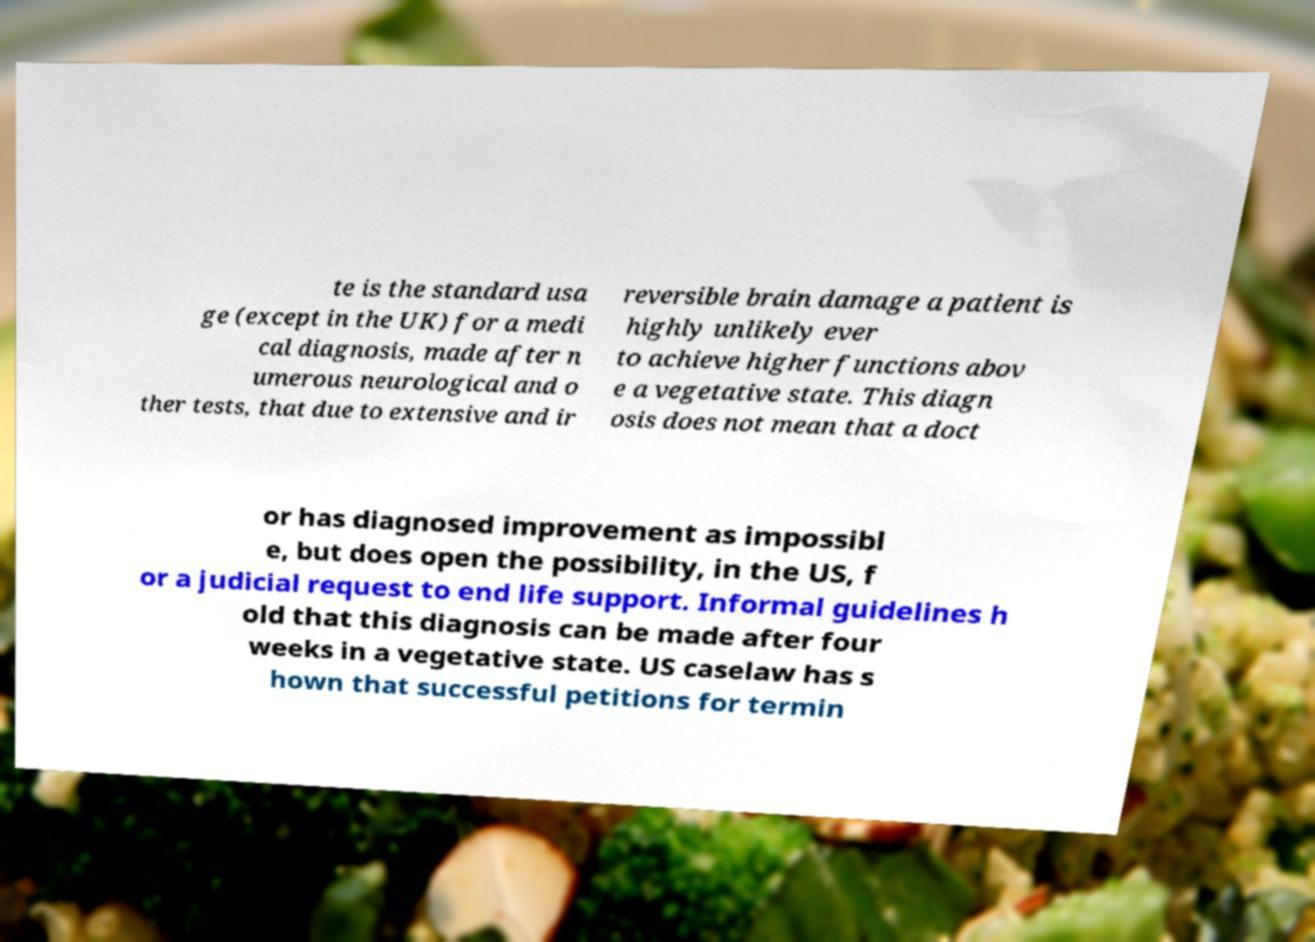Can you accurately transcribe the text from the provided image for me? te is the standard usa ge (except in the UK) for a medi cal diagnosis, made after n umerous neurological and o ther tests, that due to extensive and ir reversible brain damage a patient is highly unlikely ever to achieve higher functions abov e a vegetative state. This diagn osis does not mean that a doct or has diagnosed improvement as impossibl e, but does open the possibility, in the US, f or a judicial request to end life support. Informal guidelines h old that this diagnosis can be made after four weeks in a vegetative state. US caselaw has s hown that successful petitions for termin 